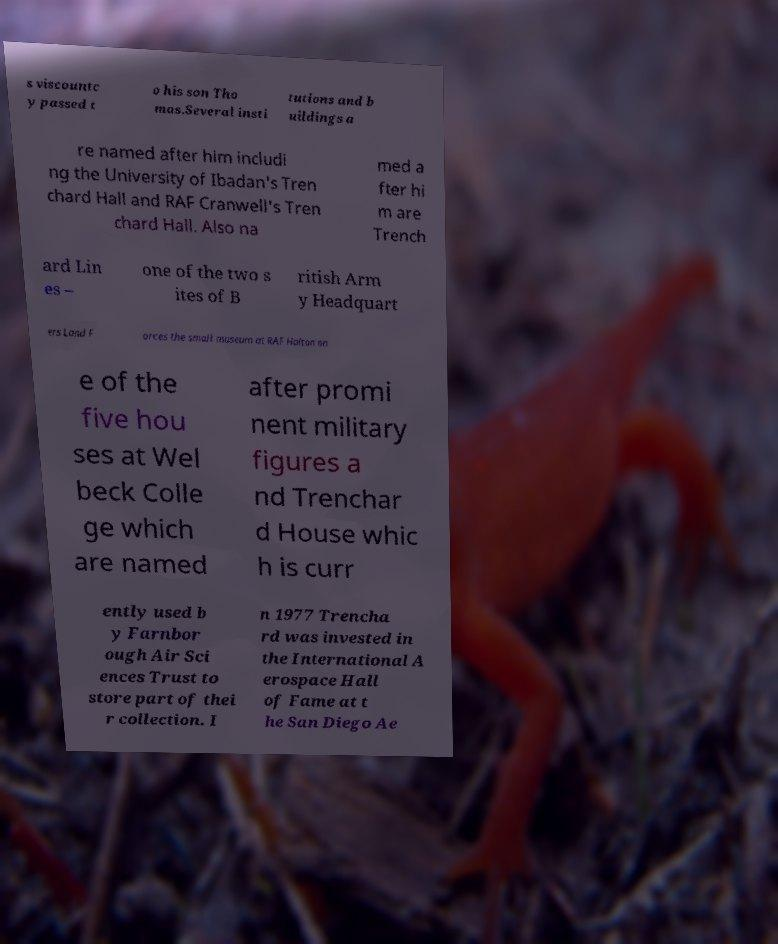Please identify and transcribe the text found in this image. s viscountc y passed t o his son Tho mas.Several insti tutions and b uildings a re named after him includi ng the University of Ibadan's Tren chard Hall and RAF Cranwell's Tren chard Hall. Also na med a fter hi m are Trench ard Lin es – one of the two s ites of B ritish Arm y Headquart ers Land F orces the small museum at RAF Halton on e of the five hou ses at Wel beck Colle ge which are named after promi nent military figures a nd Trenchar d House whic h is curr ently used b y Farnbor ough Air Sci ences Trust to store part of thei r collection. I n 1977 Trencha rd was invested in the International A erospace Hall of Fame at t he San Diego Ae 